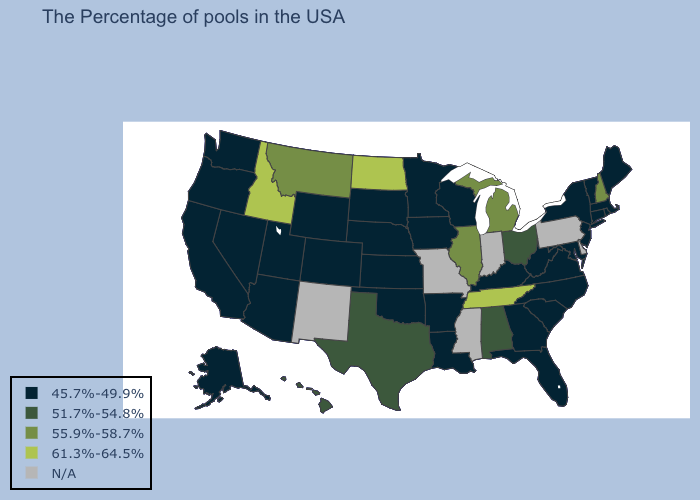What is the value of Illinois?
Keep it brief. 55.9%-58.7%. Which states have the lowest value in the USA?
Write a very short answer. Maine, Massachusetts, Rhode Island, Vermont, Connecticut, New York, New Jersey, Maryland, Virginia, North Carolina, South Carolina, West Virginia, Florida, Georgia, Kentucky, Wisconsin, Louisiana, Arkansas, Minnesota, Iowa, Kansas, Nebraska, Oklahoma, South Dakota, Wyoming, Colorado, Utah, Arizona, Nevada, California, Washington, Oregon, Alaska. Does North Dakota have the highest value in the USA?
Answer briefly. Yes. Does the first symbol in the legend represent the smallest category?
Give a very brief answer. Yes. Among the states that border Missouri , which have the lowest value?
Write a very short answer. Kentucky, Arkansas, Iowa, Kansas, Nebraska, Oklahoma. Among the states that border Kansas , which have the lowest value?
Write a very short answer. Nebraska, Oklahoma, Colorado. What is the highest value in states that border Ohio?
Give a very brief answer. 55.9%-58.7%. Does New Hampshire have the highest value in the Northeast?
Give a very brief answer. Yes. How many symbols are there in the legend?
Write a very short answer. 5. Which states have the highest value in the USA?
Short answer required. Tennessee, North Dakota, Idaho. Which states have the lowest value in the USA?
Answer briefly. Maine, Massachusetts, Rhode Island, Vermont, Connecticut, New York, New Jersey, Maryland, Virginia, North Carolina, South Carolina, West Virginia, Florida, Georgia, Kentucky, Wisconsin, Louisiana, Arkansas, Minnesota, Iowa, Kansas, Nebraska, Oklahoma, South Dakota, Wyoming, Colorado, Utah, Arizona, Nevada, California, Washington, Oregon, Alaska. What is the value of Wyoming?
Short answer required. 45.7%-49.9%. Among the states that border Iowa , which have the lowest value?
Concise answer only. Wisconsin, Minnesota, Nebraska, South Dakota. Name the states that have a value in the range 55.9%-58.7%?
Give a very brief answer. New Hampshire, Michigan, Illinois, Montana. What is the highest value in the South ?
Concise answer only. 61.3%-64.5%. 